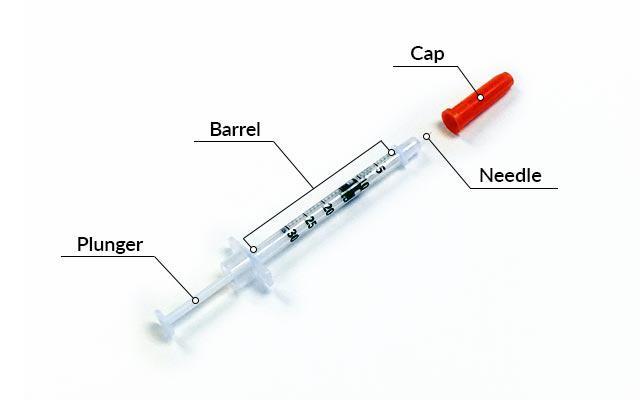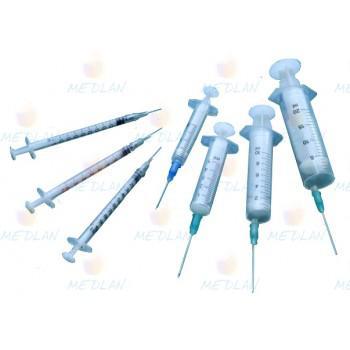The first image is the image on the left, the second image is the image on the right. Given the left and right images, does the statement "The left image contains exactly three syringes." hold true? Answer yes or no. No. The first image is the image on the left, the second image is the image on the right. For the images displayed, is the sentence "Two or more syringes are shown with their metal needles crossed over each other in at least one of the images." factually correct? Answer yes or no. No. 